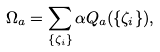<formula> <loc_0><loc_0><loc_500><loc_500>\Omega _ { a } = \sum _ { \{ \zeta _ { i } \} } \alpha Q _ { a } ( \{ \zeta _ { i } \} ) ,</formula> 